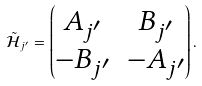<formula> <loc_0><loc_0><loc_500><loc_500>\tilde { \mathcal { H } } _ { j ^ { \prime } } = \begin{pmatrix} A _ { j ^ { \prime } } & B _ { j ^ { \prime } } \\ - B _ { j ^ { \prime } } & - A _ { j ^ { \prime } } \end{pmatrix} .</formula> 